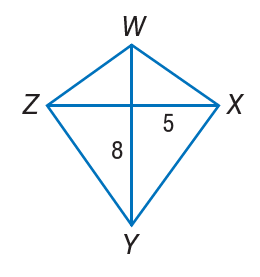Question: If W X Y Z is a kite, find Y Z.
Choices:
A. 5
B. 8
C. \sqrt { 89 }
D. 25
Answer with the letter. Answer: C 